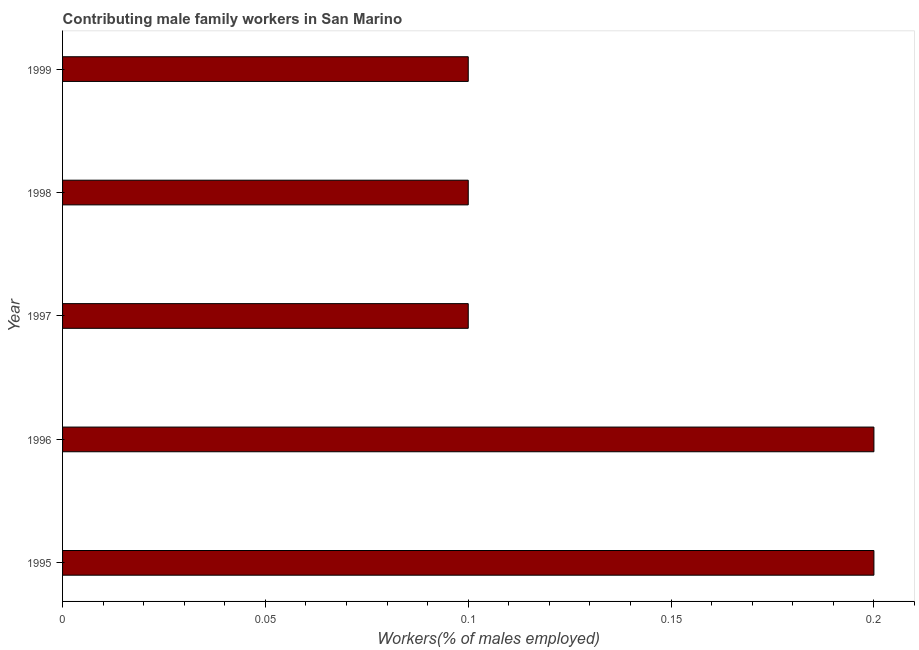Does the graph contain any zero values?
Keep it short and to the point. No. What is the title of the graph?
Your answer should be compact. Contributing male family workers in San Marino. What is the label or title of the X-axis?
Provide a succinct answer. Workers(% of males employed). What is the contributing male family workers in 1995?
Offer a very short reply. 0.2. Across all years, what is the maximum contributing male family workers?
Your answer should be very brief. 0.2. Across all years, what is the minimum contributing male family workers?
Offer a very short reply. 0.1. In which year was the contributing male family workers maximum?
Provide a short and direct response. 1995. What is the sum of the contributing male family workers?
Your answer should be very brief. 0.7. What is the average contributing male family workers per year?
Your answer should be very brief. 0.14. What is the median contributing male family workers?
Keep it short and to the point. 0.1. In how many years, is the contributing male family workers greater than 0.2 %?
Provide a short and direct response. 2. Do a majority of the years between 1998 and 1995 (inclusive) have contributing male family workers greater than 0.07 %?
Offer a very short reply. Yes. Is the difference between the contributing male family workers in 1997 and 1998 greater than the difference between any two years?
Ensure brevity in your answer.  No. In how many years, is the contributing male family workers greater than the average contributing male family workers taken over all years?
Offer a terse response. 2. How many bars are there?
Keep it short and to the point. 5. How many years are there in the graph?
Keep it short and to the point. 5. What is the difference between two consecutive major ticks on the X-axis?
Your answer should be very brief. 0.05. What is the Workers(% of males employed) in 1995?
Your answer should be very brief. 0.2. What is the Workers(% of males employed) in 1996?
Give a very brief answer. 0.2. What is the Workers(% of males employed) of 1997?
Provide a short and direct response. 0.1. What is the Workers(% of males employed) in 1998?
Provide a short and direct response. 0.1. What is the Workers(% of males employed) of 1999?
Your answer should be very brief. 0.1. What is the difference between the Workers(% of males employed) in 1995 and 1996?
Your response must be concise. 0. What is the difference between the Workers(% of males employed) in 1995 and 1998?
Your answer should be very brief. 0.1. What is the difference between the Workers(% of males employed) in 1996 and 1997?
Keep it short and to the point. 0.1. What is the difference between the Workers(% of males employed) in 1996 and 1998?
Give a very brief answer. 0.1. What is the difference between the Workers(% of males employed) in 1996 and 1999?
Make the answer very short. 0.1. What is the difference between the Workers(% of males employed) in 1997 and 1999?
Offer a very short reply. 0. What is the ratio of the Workers(% of males employed) in 1995 to that in 1996?
Offer a terse response. 1. What is the ratio of the Workers(% of males employed) in 1995 to that in 1997?
Your answer should be compact. 2. What is the ratio of the Workers(% of males employed) in 1995 to that in 1998?
Provide a succinct answer. 2. What is the ratio of the Workers(% of males employed) in 1996 to that in 1999?
Offer a very short reply. 2. What is the ratio of the Workers(% of males employed) in 1997 to that in 1998?
Make the answer very short. 1. 